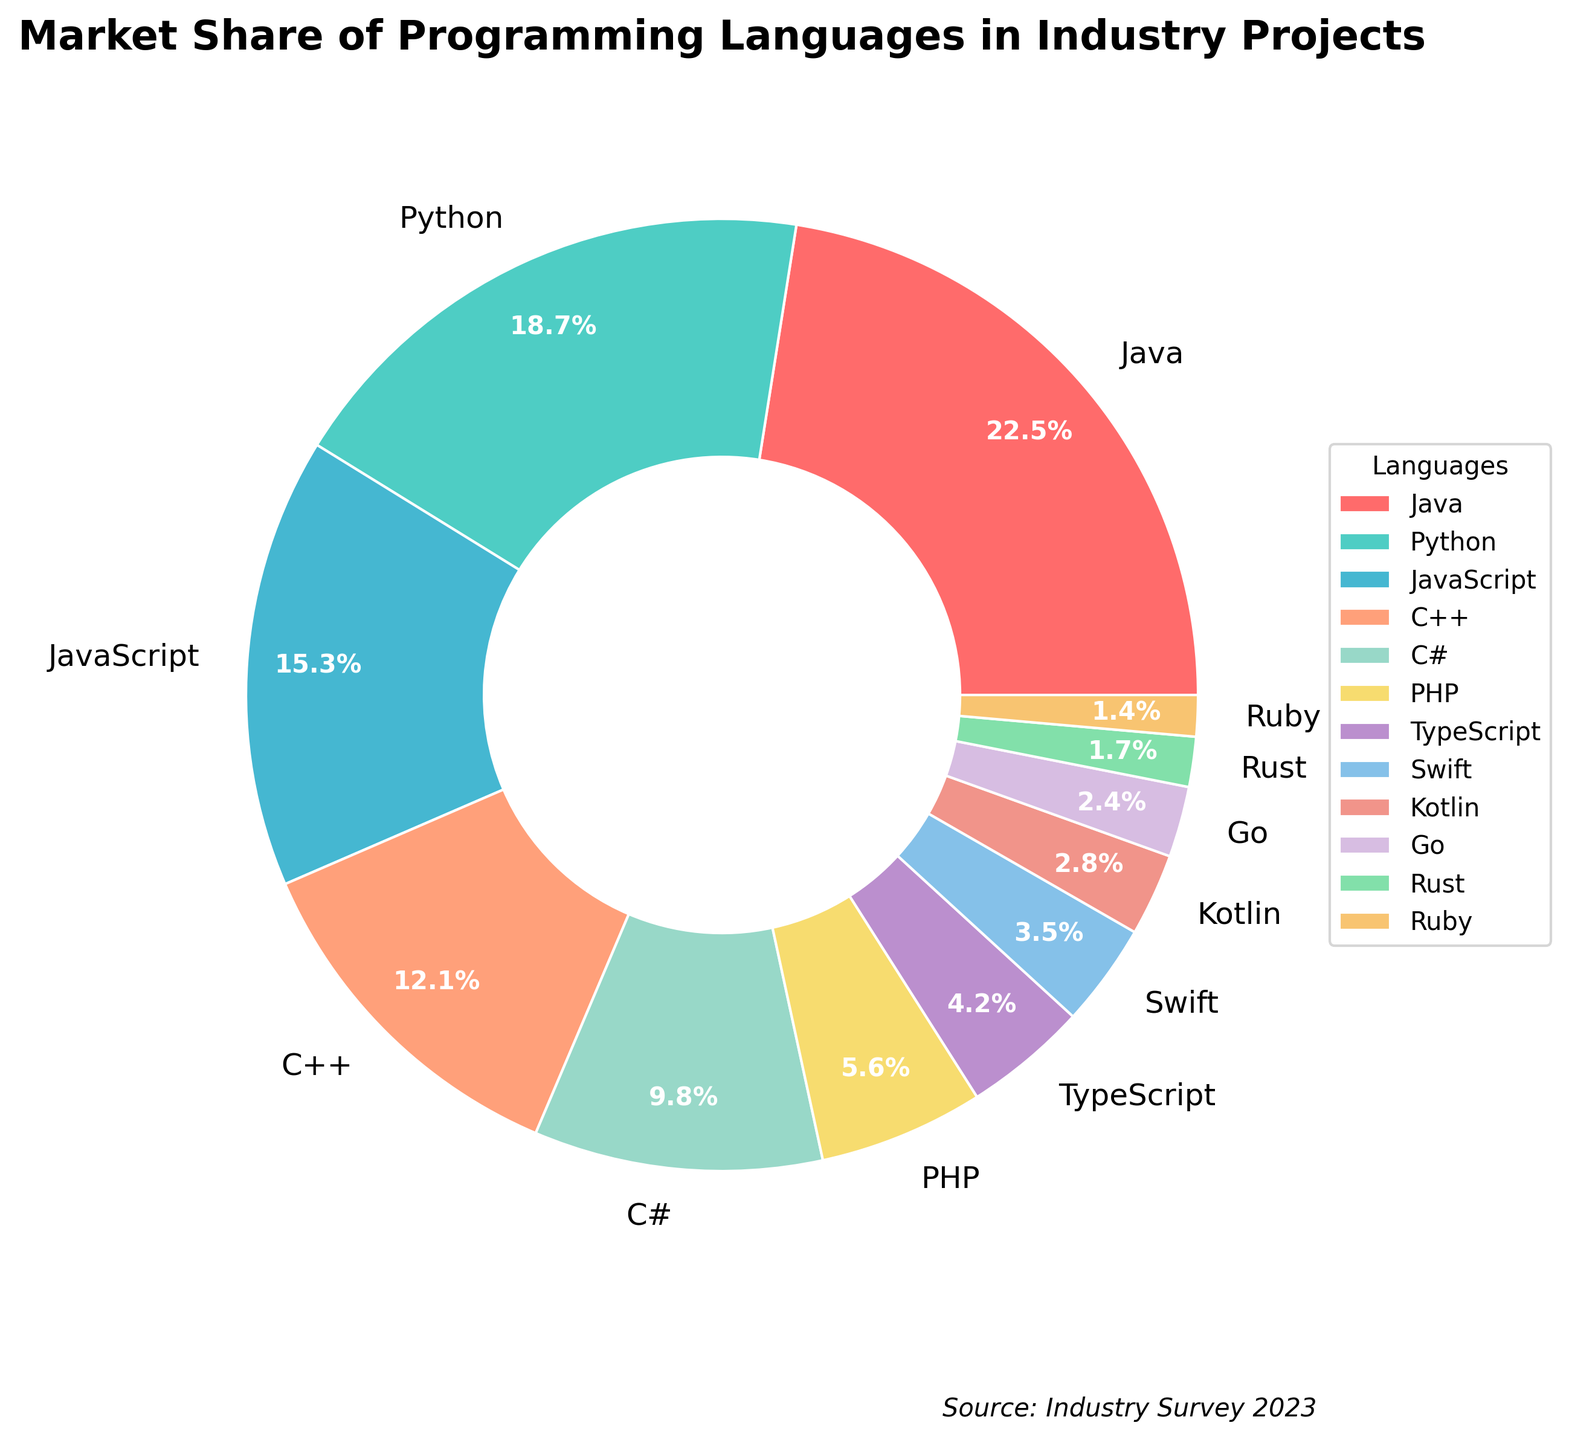What percentage of the market share do Python and JavaScript jointly hold? Add the percentages of Python (18.7%) and JavaScript (15.3%): 18.7 + 15.3 = 34%.
Answer: 34% Which language holds a larger market share, Swift or Kotlin? Compare the percentages of Swift (3.5%) and Kotlin (2.8%). Swift's share (3.5%) is greater than Kotlin's (2.8%).
Answer: Swift What is the total market share of C++ and C# combined? Sum the market shares of C++ (12.1%) and C# (9.8%): 12.1 + 9.8 = 21.9%.
Answer: 21.9% Which language has the smallest market share, and what is that percentage? The smallest market share is held by Ruby with 1.4%.
Answer: Ruby, 1.4% Is the market share of TypeScript greater than or less than 5%? The market share of TypeScript is 4.2%, which is less than 5%.
Answer: Less than What is the difference in the market share between Java and Python? Subtract Python's percentage (18.7%) from Java's percentage (22.5%): 22.5 - 18.7 = 3.8%.
Answer: 3.8% What is the combined market share of the three least popular languages? Add the percentages of Rust (1.7%), Ruby (1.4%), and Go (2.4%): 1.7 + 1.4 + 2.4 = 5.5%.
Answer: 5.5% Which language is displayed in blue on the pie chart? Languages are assigned distinct colors in the order provided in the colors list. The third color is blue, corresponding to JavaScript.
Answer: JavaScript 